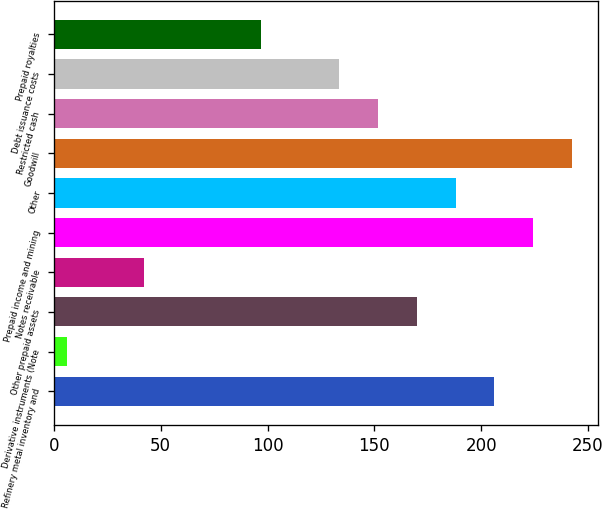Convert chart to OTSL. <chart><loc_0><loc_0><loc_500><loc_500><bar_chart><fcel>Refinery metal inventory and<fcel>Derivative instruments (Note<fcel>Other prepaid assets<fcel>Notes receivable<fcel>Prepaid income and mining<fcel>Other<fcel>Goodwill<fcel>Restricted cash<fcel>Debt issuance costs<fcel>Prepaid royalties<nl><fcel>206.2<fcel>6<fcel>169.8<fcel>42.4<fcel>224.4<fcel>188<fcel>242.6<fcel>151.6<fcel>133.4<fcel>97<nl></chart> 